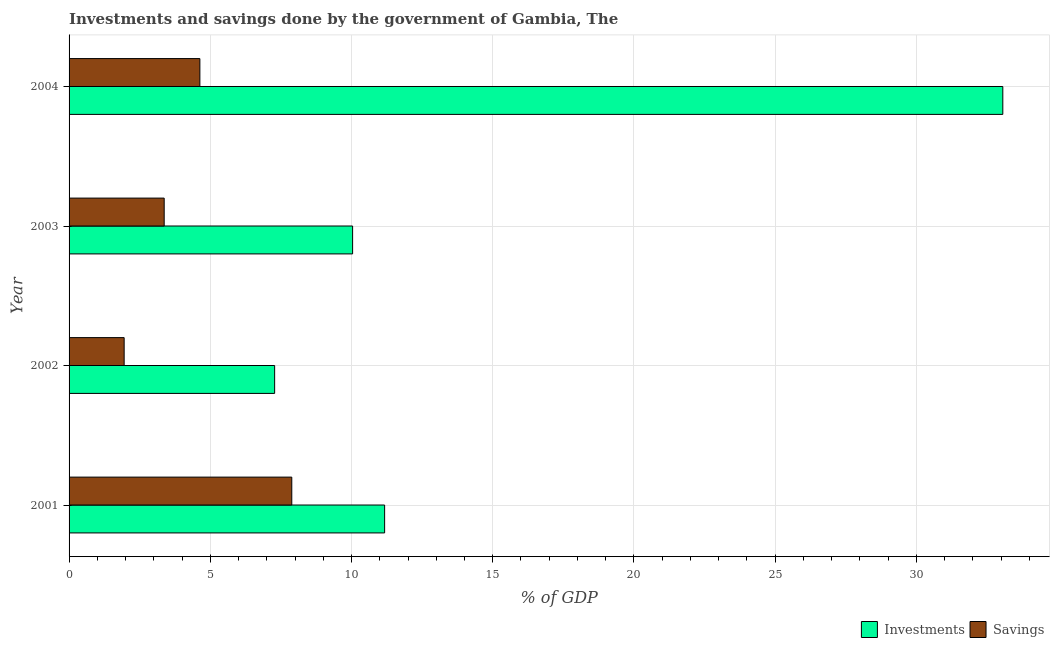How many groups of bars are there?
Offer a terse response. 4. Are the number of bars on each tick of the Y-axis equal?
Give a very brief answer. Yes. How many bars are there on the 1st tick from the bottom?
Offer a terse response. 2. What is the savings of government in 2002?
Provide a succinct answer. 1.95. Across all years, what is the maximum savings of government?
Your answer should be very brief. 7.89. Across all years, what is the minimum investments of government?
Ensure brevity in your answer.  7.28. In which year was the savings of government maximum?
Provide a short and direct response. 2001. What is the total savings of government in the graph?
Provide a succinct answer. 17.83. What is the difference between the investments of government in 2001 and that in 2002?
Your answer should be compact. 3.89. What is the difference between the investments of government in 2002 and the savings of government in 2004?
Offer a very short reply. 2.65. What is the average savings of government per year?
Your response must be concise. 4.46. In the year 2003, what is the difference between the investments of government and savings of government?
Provide a succinct answer. 6.67. What is the ratio of the savings of government in 2002 to that in 2004?
Offer a terse response. 0.42. Is the difference between the savings of government in 2001 and 2002 greater than the difference between the investments of government in 2001 and 2002?
Give a very brief answer. Yes. What is the difference between the highest and the second highest savings of government?
Offer a very short reply. 3.25. What is the difference between the highest and the lowest savings of government?
Provide a short and direct response. 5.93. In how many years, is the savings of government greater than the average savings of government taken over all years?
Offer a very short reply. 2. Is the sum of the savings of government in 2003 and 2004 greater than the maximum investments of government across all years?
Keep it short and to the point. No. What does the 1st bar from the top in 2003 represents?
Ensure brevity in your answer.  Savings. What does the 1st bar from the bottom in 2002 represents?
Give a very brief answer. Investments. How many bars are there?
Provide a succinct answer. 8. How many years are there in the graph?
Your answer should be compact. 4. What is the difference between two consecutive major ticks on the X-axis?
Your response must be concise. 5. Are the values on the major ticks of X-axis written in scientific E-notation?
Keep it short and to the point. No. Does the graph contain grids?
Offer a terse response. Yes. How are the legend labels stacked?
Your answer should be very brief. Horizontal. What is the title of the graph?
Keep it short and to the point. Investments and savings done by the government of Gambia, The. Does "Nonresident" appear as one of the legend labels in the graph?
Make the answer very short. No. What is the label or title of the X-axis?
Make the answer very short. % of GDP. What is the label or title of the Y-axis?
Provide a succinct answer. Year. What is the % of GDP of Investments in 2001?
Your answer should be compact. 11.17. What is the % of GDP of Savings in 2001?
Offer a very short reply. 7.89. What is the % of GDP in Investments in 2002?
Your response must be concise. 7.28. What is the % of GDP of Savings in 2002?
Your response must be concise. 1.95. What is the % of GDP in Investments in 2003?
Provide a short and direct response. 10.04. What is the % of GDP of Savings in 2003?
Your response must be concise. 3.37. What is the % of GDP of Investments in 2004?
Keep it short and to the point. 33.06. What is the % of GDP in Savings in 2004?
Your answer should be very brief. 4.63. Across all years, what is the maximum % of GDP of Investments?
Offer a terse response. 33.06. Across all years, what is the maximum % of GDP in Savings?
Keep it short and to the point. 7.89. Across all years, what is the minimum % of GDP of Investments?
Keep it short and to the point. 7.28. Across all years, what is the minimum % of GDP in Savings?
Offer a very short reply. 1.95. What is the total % of GDP in Investments in the graph?
Make the answer very short. 61.55. What is the total % of GDP in Savings in the graph?
Your answer should be compact. 17.83. What is the difference between the % of GDP in Investments in 2001 and that in 2002?
Make the answer very short. 3.89. What is the difference between the % of GDP of Savings in 2001 and that in 2002?
Offer a terse response. 5.93. What is the difference between the % of GDP of Investments in 2001 and that in 2003?
Offer a terse response. 1.13. What is the difference between the % of GDP of Savings in 2001 and that in 2003?
Ensure brevity in your answer.  4.52. What is the difference between the % of GDP in Investments in 2001 and that in 2004?
Offer a very short reply. -21.89. What is the difference between the % of GDP in Savings in 2001 and that in 2004?
Your answer should be very brief. 3.25. What is the difference between the % of GDP in Investments in 2002 and that in 2003?
Your response must be concise. -2.76. What is the difference between the % of GDP of Savings in 2002 and that in 2003?
Offer a terse response. -1.42. What is the difference between the % of GDP in Investments in 2002 and that in 2004?
Provide a short and direct response. -25.78. What is the difference between the % of GDP of Savings in 2002 and that in 2004?
Offer a very short reply. -2.68. What is the difference between the % of GDP in Investments in 2003 and that in 2004?
Your response must be concise. -23.02. What is the difference between the % of GDP of Savings in 2003 and that in 2004?
Your answer should be very brief. -1.26. What is the difference between the % of GDP of Investments in 2001 and the % of GDP of Savings in 2002?
Your answer should be compact. 9.22. What is the difference between the % of GDP in Investments in 2001 and the % of GDP in Savings in 2003?
Offer a terse response. 7.81. What is the difference between the % of GDP in Investments in 2001 and the % of GDP in Savings in 2004?
Ensure brevity in your answer.  6.54. What is the difference between the % of GDP in Investments in 2002 and the % of GDP in Savings in 2003?
Give a very brief answer. 3.91. What is the difference between the % of GDP of Investments in 2002 and the % of GDP of Savings in 2004?
Provide a succinct answer. 2.65. What is the difference between the % of GDP of Investments in 2003 and the % of GDP of Savings in 2004?
Your response must be concise. 5.41. What is the average % of GDP in Investments per year?
Make the answer very short. 15.39. What is the average % of GDP in Savings per year?
Give a very brief answer. 4.46. In the year 2001, what is the difference between the % of GDP in Investments and % of GDP in Savings?
Your answer should be compact. 3.29. In the year 2002, what is the difference between the % of GDP in Investments and % of GDP in Savings?
Ensure brevity in your answer.  5.33. In the year 2003, what is the difference between the % of GDP in Investments and % of GDP in Savings?
Ensure brevity in your answer.  6.67. In the year 2004, what is the difference between the % of GDP of Investments and % of GDP of Savings?
Provide a short and direct response. 28.43. What is the ratio of the % of GDP of Investments in 2001 to that in 2002?
Provide a succinct answer. 1.54. What is the ratio of the % of GDP of Savings in 2001 to that in 2002?
Offer a terse response. 4.04. What is the ratio of the % of GDP of Investments in 2001 to that in 2003?
Keep it short and to the point. 1.11. What is the ratio of the % of GDP of Savings in 2001 to that in 2003?
Your response must be concise. 2.34. What is the ratio of the % of GDP of Investments in 2001 to that in 2004?
Provide a short and direct response. 0.34. What is the ratio of the % of GDP of Savings in 2001 to that in 2004?
Provide a short and direct response. 1.7. What is the ratio of the % of GDP of Investments in 2002 to that in 2003?
Give a very brief answer. 0.72. What is the ratio of the % of GDP in Savings in 2002 to that in 2003?
Your answer should be compact. 0.58. What is the ratio of the % of GDP in Investments in 2002 to that in 2004?
Your response must be concise. 0.22. What is the ratio of the % of GDP of Savings in 2002 to that in 2004?
Provide a short and direct response. 0.42. What is the ratio of the % of GDP of Investments in 2003 to that in 2004?
Make the answer very short. 0.3. What is the ratio of the % of GDP of Savings in 2003 to that in 2004?
Make the answer very short. 0.73. What is the difference between the highest and the second highest % of GDP in Investments?
Your answer should be compact. 21.89. What is the difference between the highest and the second highest % of GDP in Savings?
Ensure brevity in your answer.  3.25. What is the difference between the highest and the lowest % of GDP of Investments?
Offer a terse response. 25.78. What is the difference between the highest and the lowest % of GDP in Savings?
Give a very brief answer. 5.93. 